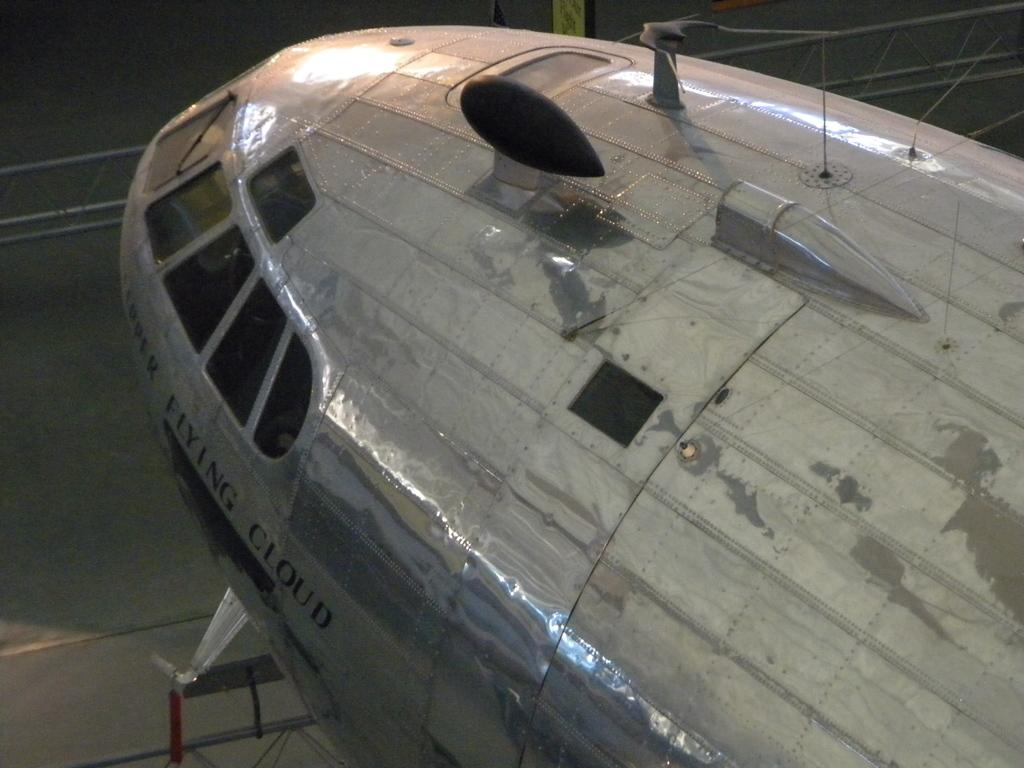Provide a one-sentence caption for the provided image. An airplane covered in steel plating is named after a cloud. 